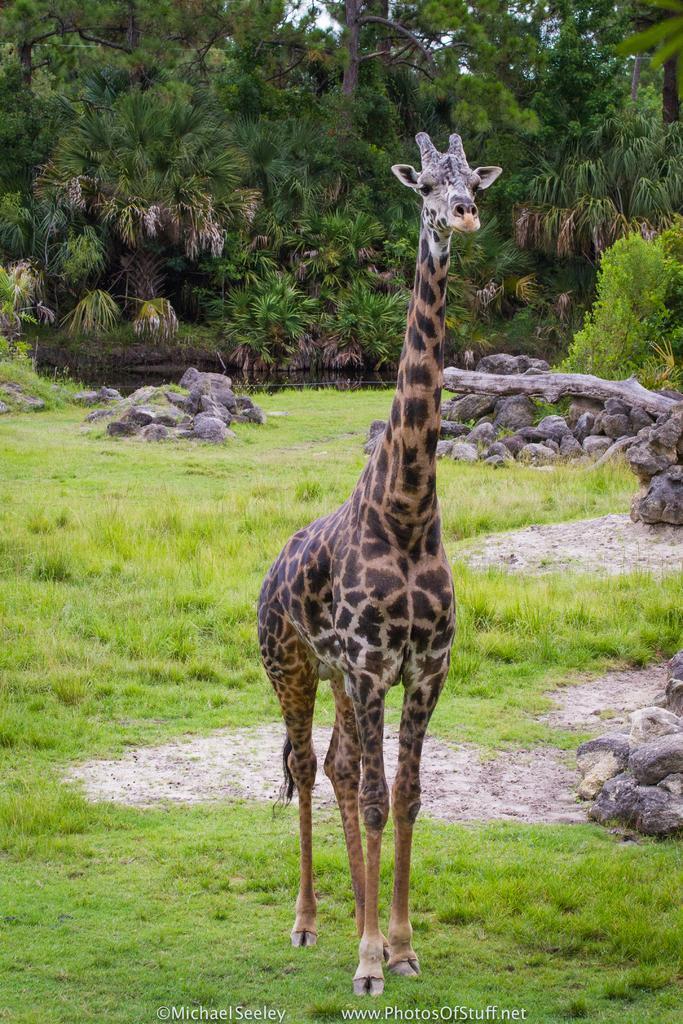Can you describe this image briefly? This image consists of a giraffe. At the bottom, there is green grass. And we can see the rocks on the ground. In the background, there are trees. 